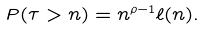Convert formula to latex. <formula><loc_0><loc_0><loc_500><loc_500>P ( \tau > n ) = n ^ { \rho - 1 } \ell ( n ) .</formula> 